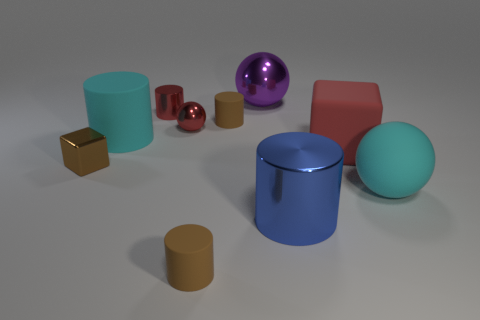Are there more metal things than objects?
Keep it short and to the point. No. Is there a cylinder that has the same color as the small cube?
Offer a terse response. Yes. There is a block right of the purple thing; does it have the same size as the brown cube?
Your answer should be very brief. No. Is the number of tiny red shiny objects less than the number of large blue cylinders?
Provide a succinct answer. No. Are there any cylinders that have the same material as the red sphere?
Your response must be concise. Yes. What shape is the red metal thing that is in front of the red cylinder?
Ensure brevity in your answer.  Sphere. Does the sphere that is in front of the tiny brown block have the same color as the large matte cylinder?
Give a very brief answer. Yes. Are there fewer brown metallic blocks behind the tiny red cylinder than small blue objects?
Provide a short and direct response. No. There is a ball that is the same material as the red block; what is its color?
Make the answer very short. Cyan. What is the size of the cube on the right side of the blue metallic cylinder?
Give a very brief answer. Large. 